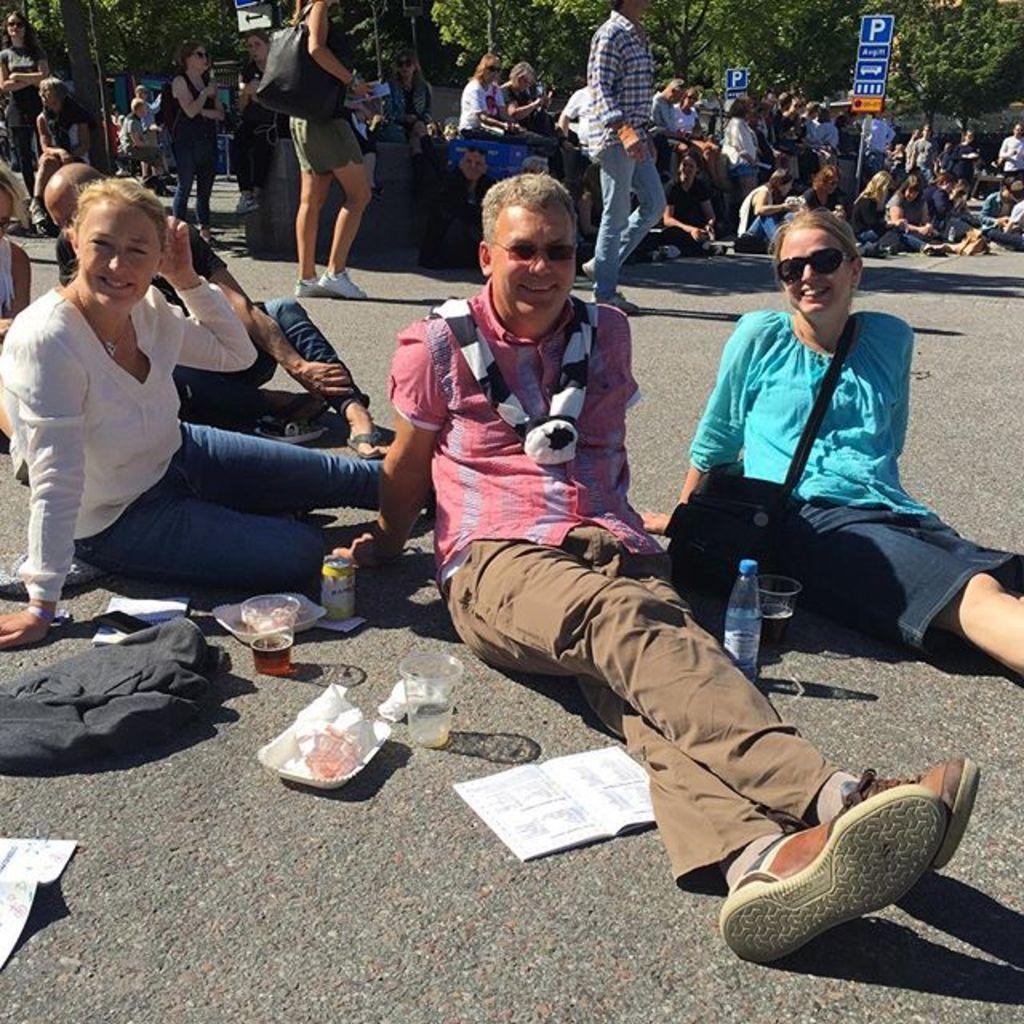How would you summarize this image in a sentence or two? In the center of the image we can see some persons are sitting on the road and we can see some objects like glasses, plate, paper, book, bottles, bags, cloth are present. At the top of the image a group of people are there and we can see some boards, trees are present. 